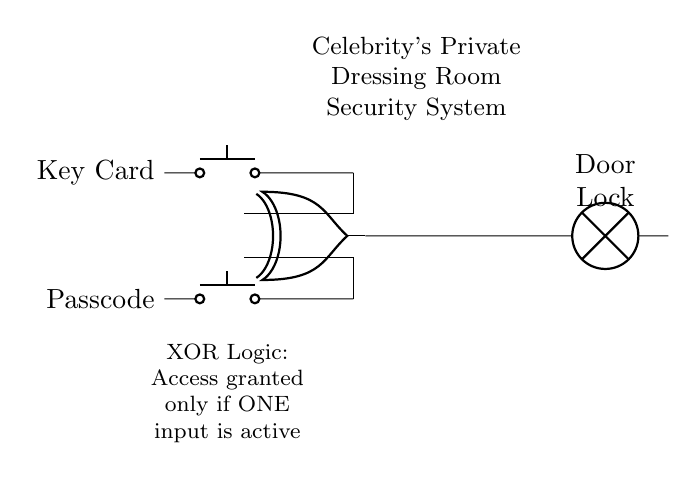What components are present in this circuit? The circuit contains two push buttons and an XOR logic gate. The push buttons represent inputs for key card and passcode, while the XOR gate processes these inputs to control the door lock.
Answer: Two push buttons and one XOR gate What does the XOR gate indicate about access? The XOR gate processes the inputs such that access is granted only when one, but not both, of the inputs (key card or passcode) is active. This ensures the system's security by requiring either a card or a code, but not both.
Answer: Access granted if one input is active How many total inputs does this circuit have? There are two inputs in the circuit: one for the key card and one for the passcode, which are both connected to the XOR gate.
Answer: Two inputs What happens if both inputs are activated? If both inputs are activated, the XOR gate outputs no signal, and hence the door remains locked. This is due to the gate’s property that it outputs true only when there is a disparity between its inputs.
Answer: The door remains locked What type of logic gate is used in this circuit? The circuit uses an XOR gate, which is characterized by its ability to output true only when an odd number of its inputs are true.
Answer: XOR gate What is the output of the circuit if only the key card is pressed? If only the key card is pressed, the output of the XOR gate will be true, allowing the door to unlock. This aligns with the XOR gate functioning which allows for one active input.
Answer: Door unlocks 